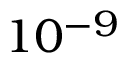<formula> <loc_0><loc_0><loc_500><loc_500>1 0 ^ { - 9 }</formula> 